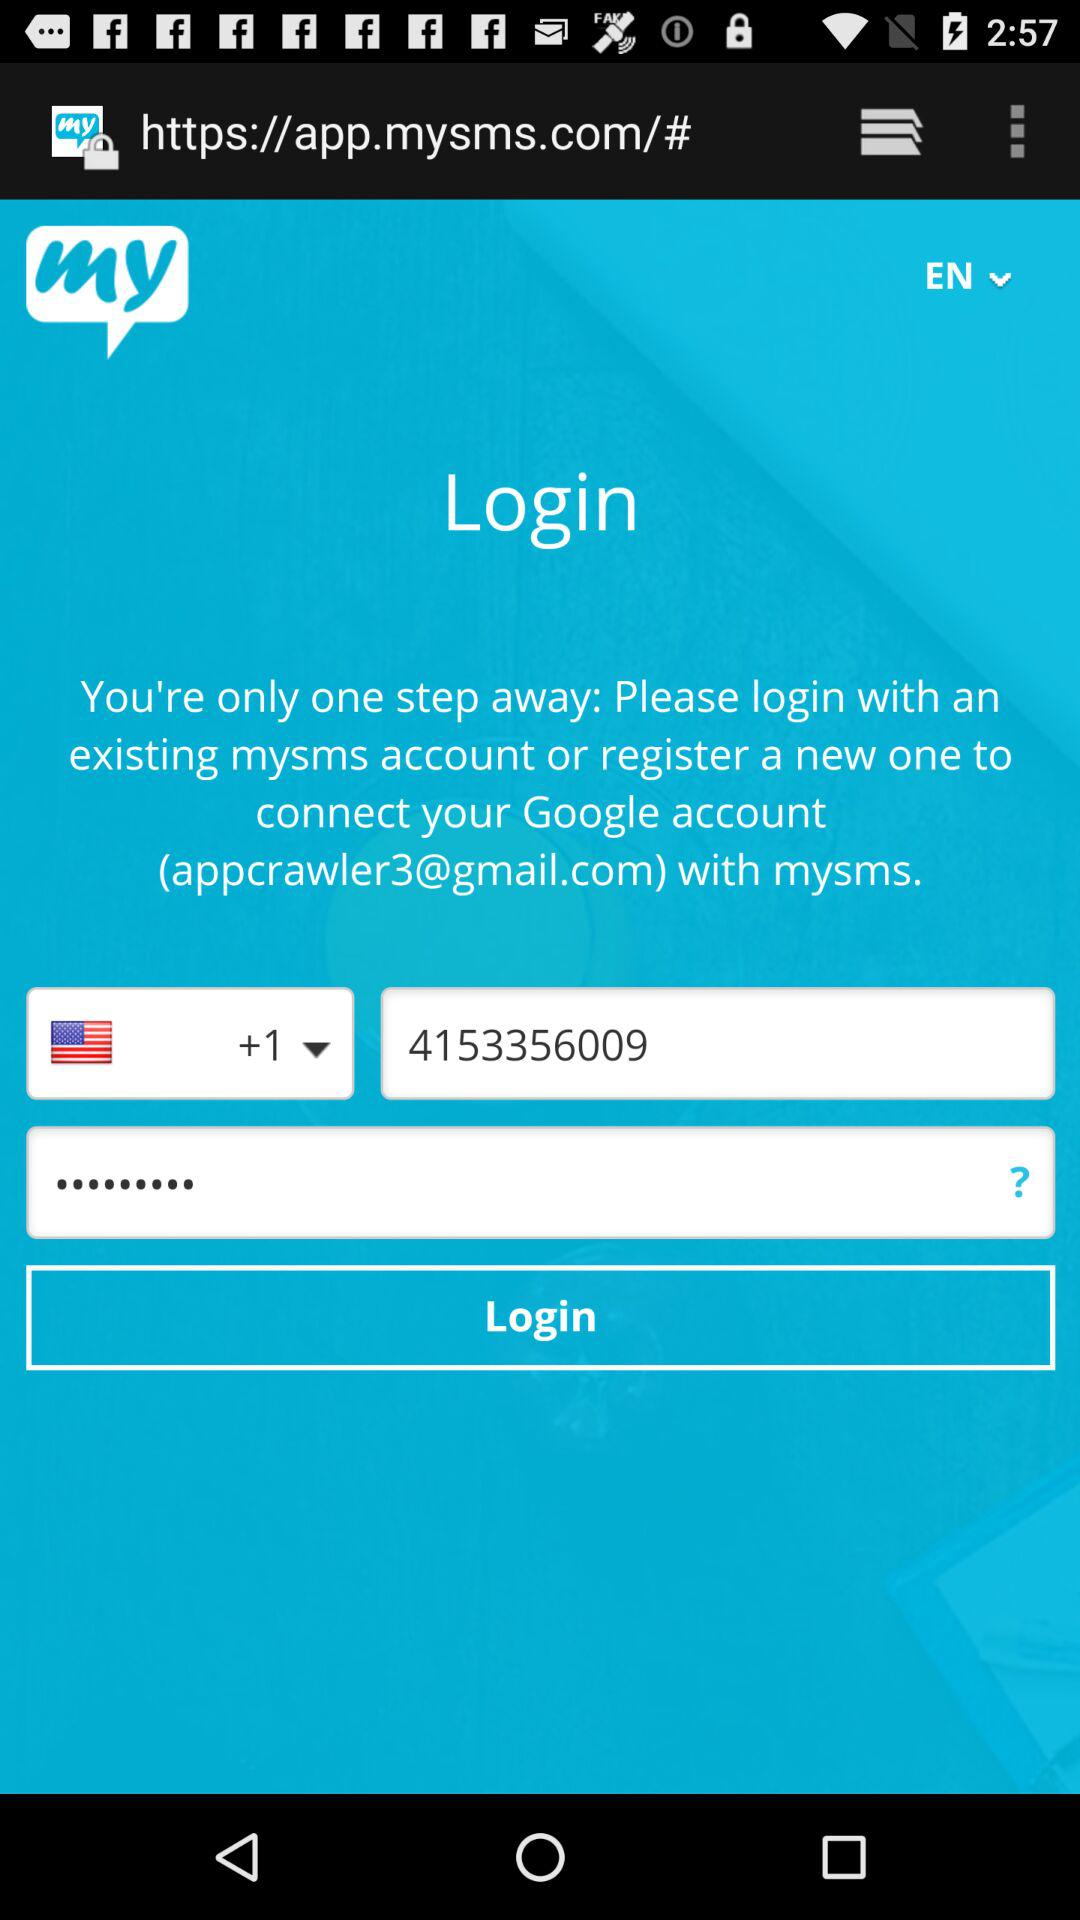What is the phone number? The phone number is +1 4153356009. 